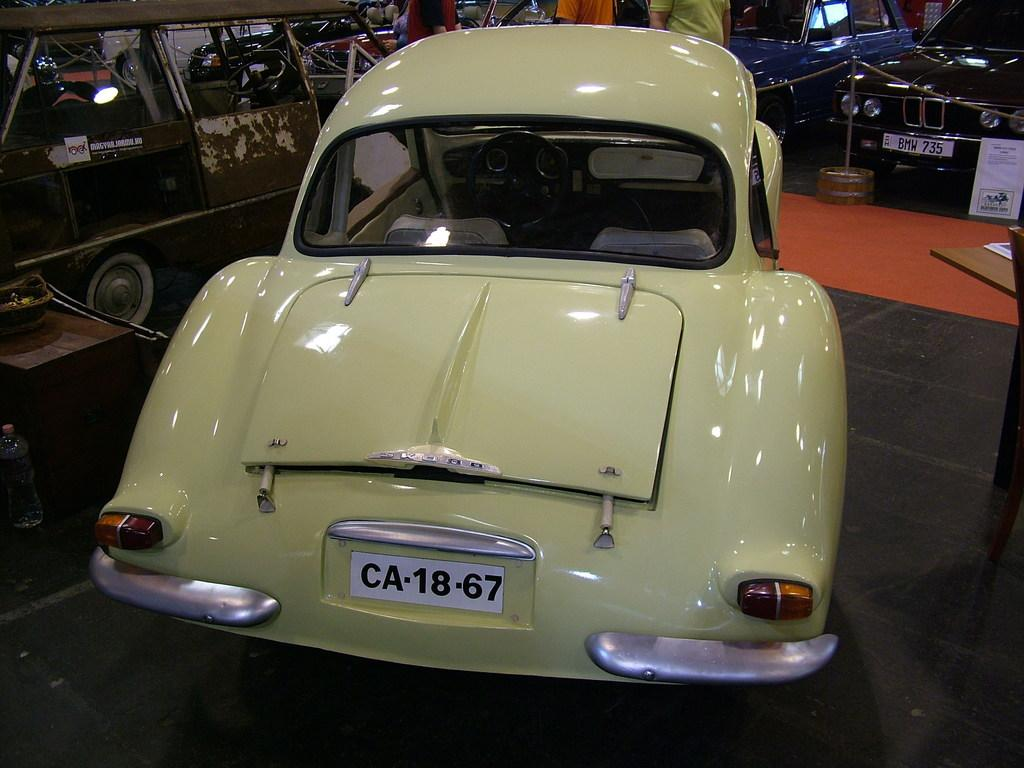What is the main subject in the middle of the image? There is a car in the middle of the image. What is at the bottom of the image? There is a floor at the bottom of the image. What can be seen in the background of the image? There are cars, people, posters, and poles in the background of the image. Can you describe the board in the background of the image? There is a board in the background of the image. What type of basin is used for washing hands in the image? There is no basin present in the image for washing hands. What kind of quilt is covering the car in the image? There is no quilt covering the car in the image. 